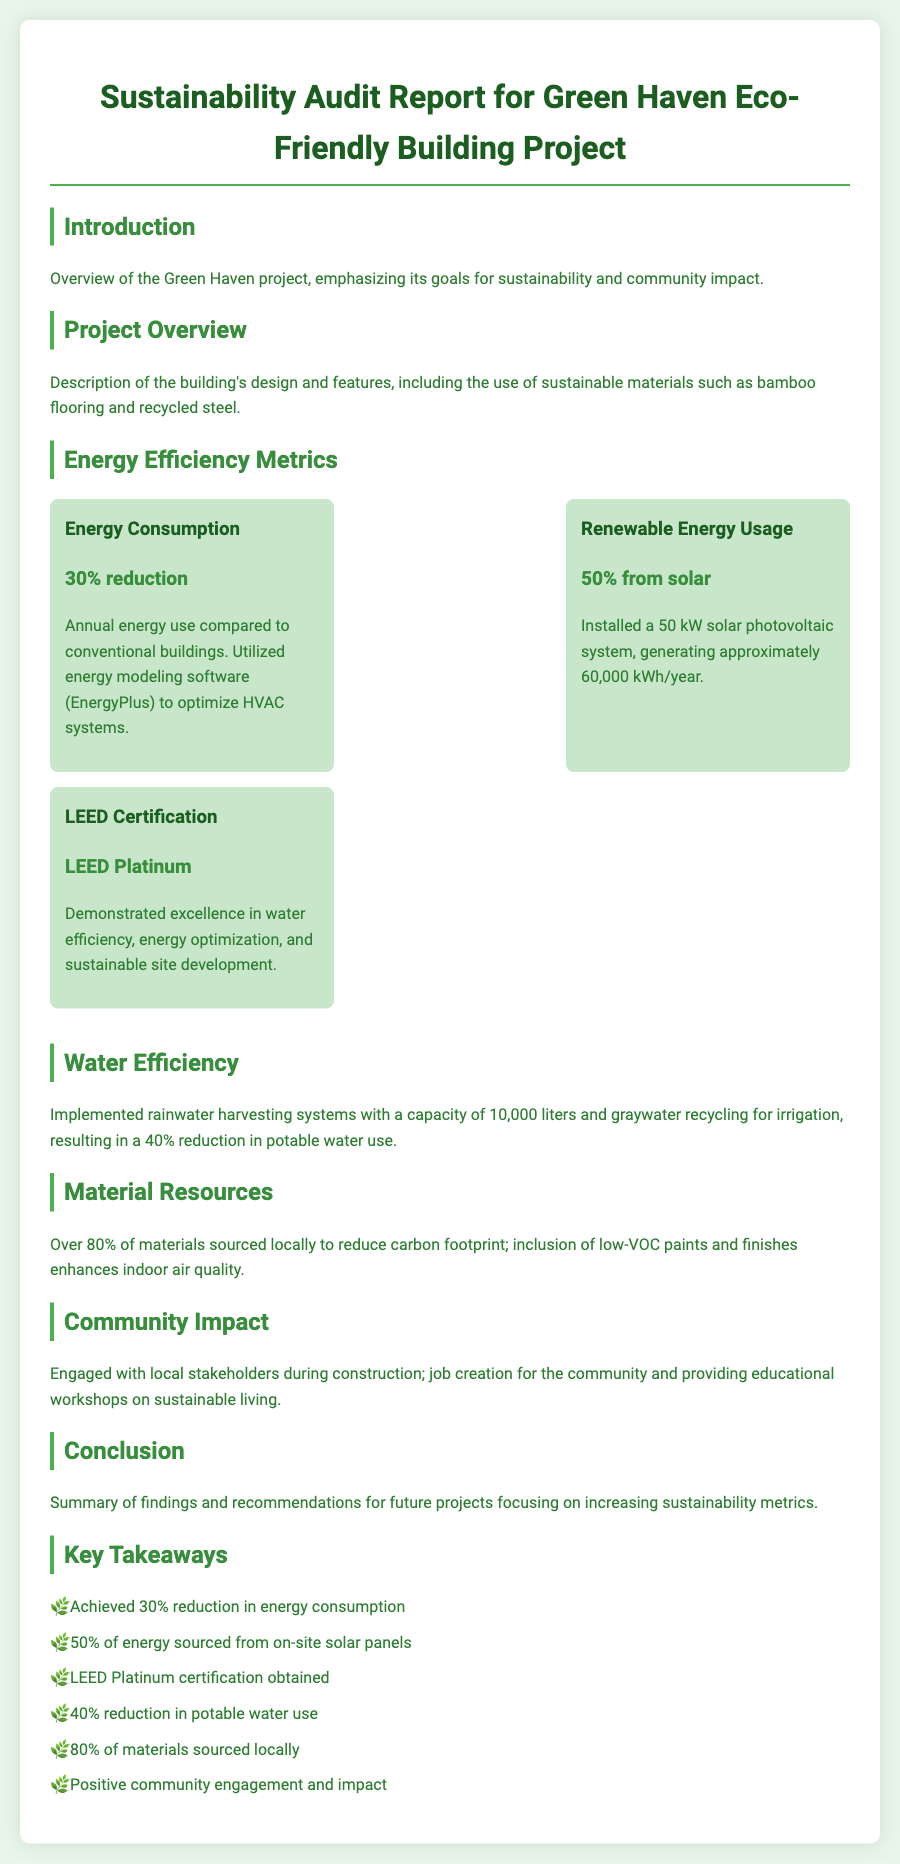What is the energy consumption reduction? The energy consumption reduction is stated in the document, highlighting the project's efficiency.
Answer: 30% reduction What percentage of energy usage comes from solar power? The document specifically mentions the source of energy used by the building.
Answer: 50% from solar What is the LEED certification level achieved? The document provides details about the LEED certification awarded to the project.
Answer: LEED Platinum What is the capacity of the rainwater harvesting system? The document describes the rainwater harvesting system in terms of capacity.
Answer: 10,000 liters What percentage of materials were sourced locally? The document emphasizes the sourcing of materials for sustainability.
Answer: Over 80% How much energy does the solar photovoltaic system generate annually? The document specifies the annual energy generation from the solar system.
Answer: Approximately 60,000 kWh/year What was the reduction percentage in potable water use? The document addresses water efficiency and its impact on consumption.
Answer: 40% reduction What type of paint was used to enhance indoor air quality? The document mentions a specific characteristic of the paints used in the building.
Answer: Low-VOC paints What community engagement activities were mentioned? The document highlights the project's engagement with local stakeholders during construction.
Answer: Job creation and educational workshops 